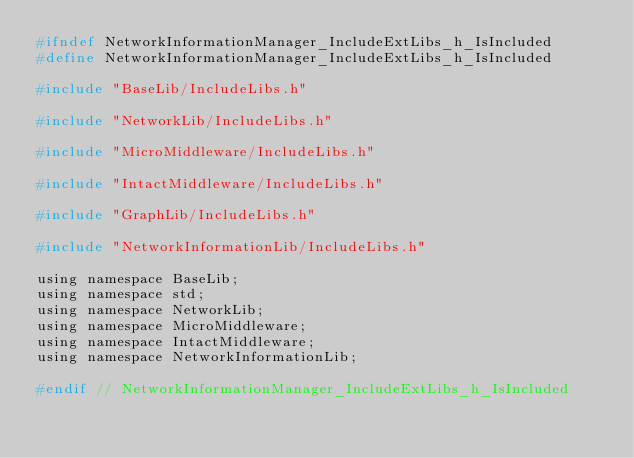<code> <loc_0><loc_0><loc_500><loc_500><_C_>#ifndef NetworkInformationManager_IncludeExtLibs_h_IsIncluded
#define NetworkInformationManager_IncludeExtLibs_h_IsIncluded

#include "BaseLib/IncludeLibs.h"

#include "NetworkLib/IncludeLibs.h"

#include "MicroMiddleware/IncludeLibs.h"

#include "IntactMiddleware/IncludeLibs.h"

#include "GraphLib/IncludeLibs.h"

#include "NetworkInformationLib/IncludeLibs.h"

using namespace BaseLib;
using namespace std;
using namespace NetworkLib;
using namespace MicroMiddleware;
using namespace IntactMiddleware;
using namespace NetworkInformationLib;

#endif // NetworkInformationManager_IncludeExtLibs_h_IsIncluded

</code> 